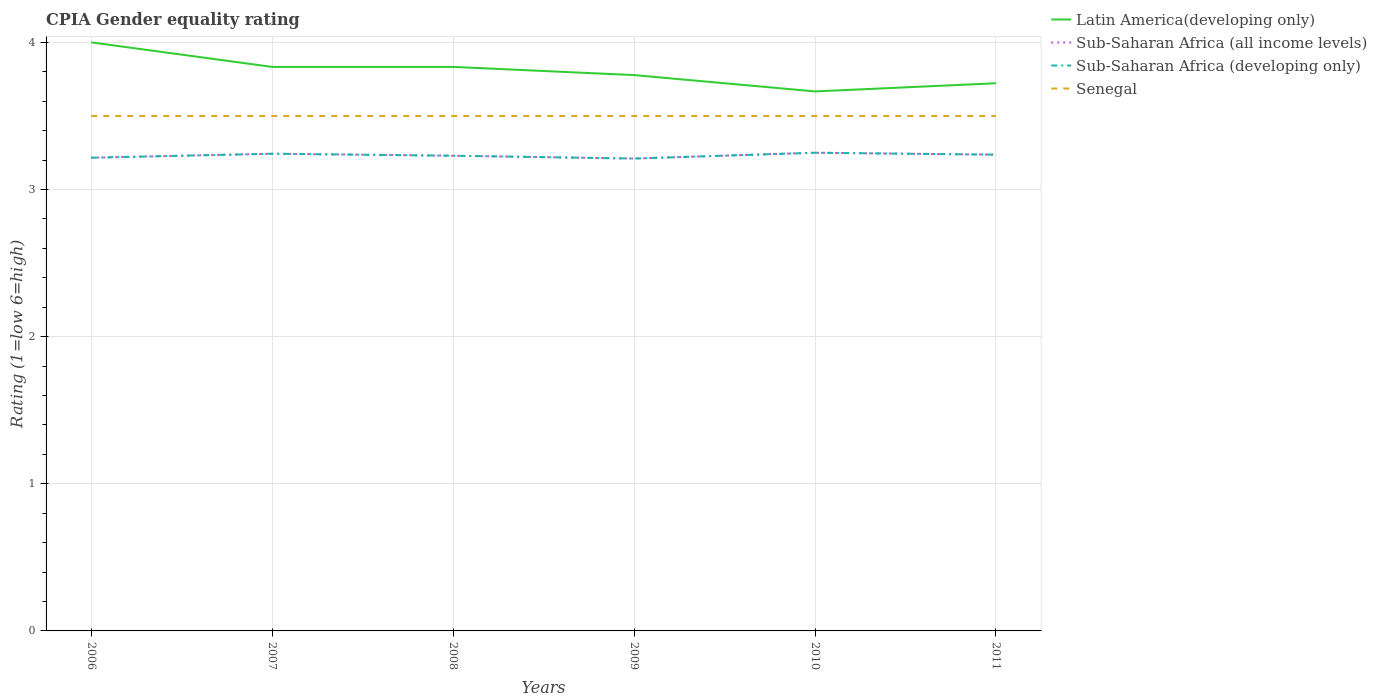How many different coloured lines are there?
Ensure brevity in your answer.  4. Does the line corresponding to Sub-Saharan Africa (developing only) intersect with the line corresponding to Latin America(developing only)?
Ensure brevity in your answer.  No. Across all years, what is the maximum CPIA rating in Sub-Saharan Africa (all income levels)?
Provide a short and direct response. 3.21. What is the total CPIA rating in Sub-Saharan Africa (all income levels) in the graph?
Offer a terse response. -0.02. What is the difference between the highest and the second highest CPIA rating in Sub-Saharan Africa (developing only)?
Ensure brevity in your answer.  0.04. Is the CPIA rating in Latin America(developing only) strictly greater than the CPIA rating in Senegal over the years?
Offer a terse response. No. Are the values on the major ticks of Y-axis written in scientific E-notation?
Keep it short and to the point. No. Does the graph contain grids?
Your answer should be compact. Yes. Where does the legend appear in the graph?
Offer a very short reply. Top right. How many legend labels are there?
Your answer should be very brief. 4. How are the legend labels stacked?
Keep it short and to the point. Vertical. What is the title of the graph?
Provide a short and direct response. CPIA Gender equality rating. Does "Azerbaijan" appear as one of the legend labels in the graph?
Your answer should be compact. No. What is the Rating (1=low 6=high) of Sub-Saharan Africa (all income levels) in 2006?
Your answer should be very brief. 3.22. What is the Rating (1=low 6=high) of Sub-Saharan Africa (developing only) in 2006?
Your answer should be compact. 3.22. What is the Rating (1=low 6=high) of Senegal in 2006?
Keep it short and to the point. 3.5. What is the Rating (1=low 6=high) of Latin America(developing only) in 2007?
Provide a short and direct response. 3.83. What is the Rating (1=low 6=high) of Sub-Saharan Africa (all income levels) in 2007?
Ensure brevity in your answer.  3.24. What is the Rating (1=low 6=high) in Sub-Saharan Africa (developing only) in 2007?
Keep it short and to the point. 3.24. What is the Rating (1=low 6=high) in Senegal in 2007?
Make the answer very short. 3.5. What is the Rating (1=low 6=high) in Latin America(developing only) in 2008?
Your answer should be compact. 3.83. What is the Rating (1=low 6=high) of Sub-Saharan Africa (all income levels) in 2008?
Your answer should be very brief. 3.23. What is the Rating (1=low 6=high) in Sub-Saharan Africa (developing only) in 2008?
Give a very brief answer. 3.23. What is the Rating (1=low 6=high) in Senegal in 2008?
Your answer should be compact. 3.5. What is the Rating (1=low 6=high) of Latin America(developing only) in 2009?
Offer a very short reply. 3.78. What is the Rating (1=low 6=high) of Sub-Saharan Africa (all income levels) in 2009?
Your response must be concise. 3.21. What is the Rating (1=low 6=high) in Sub-Saharan Africa (developing only) in 2009?
Ensure brevity in your answer.  3.21. What is the Rating (1=low 6=high) of Latin America(developing only) in 2010?
Ensure brevity in your answer.  3.67. What is the Rating (1=low 6=high) of Sub-Saharan Africa (developing only) in 2010?
Offer a very short reply. 3.25. What is the Rating (1=low 6=high) in Latin America(developing only) in 2011?
Give a very brief answer. 3.72. What is the Rating (1=low 6=high) of Sub-Saharan Africa (all income levels) in 2011?
Offer a very short reply. 3.24. What is the Rating (1=low 6=high) of Sub-Saharan Africa (developing only) in 2011?
Your answer should be compact. 3.24. Across all years, what is the maximum Rating (1=low 6=high) in Sub-Saharan Africa (all income levels)?
Offer a very short reply. 3.25. Across all years, what is the maximum Rating (1=low 6=high) of Sub-Saharan Africa (developing only)?
Provide a succinct answer. 3.25. Across all years, what is the maximum Rating (1=low 6=high) of Senegal?
Provide a succinct answer. 3.5. Across all years, what is the minimum Rating (1=low 6=high) in Latin America(developing only)?
Offer a terse response. 3.67. Across all years, what is the minimum Rating (1=low 6=high) of Sub-Saharan Africa (all income levels)?
Your answer should be compact. 3.21. Across all years, what is the minimum Rating (1=low 6=high) in Sub-Saharan Africa (developing only)?
Your answer should be very brief. 3.21. Across all years, what is the minimum Rating (1=low 6=high) in Senegal?
Ensure brevity in your answer.  3.5. What is the total Rating (1=low 6=high) in Latin America(developing only) in the graph?
Provide a succinct answer. 22.83. What is the total Rating (1=low 6=high) in Sub-Saharan Africa (all income levels) in the graph?
Give a very brief answer. 19.39. What is the total Rating (1=low 6=high) of Sub-Saharan Africa (developing only) in the graph?
Provide a short and direct response. 19.39. What is the total Rating (1=low 6=high) of Senegal in the graph?
Provide a succinct answer. 21. What is the difference between the Rating (1=low 6=high) in Latin America(developing only) in 2006 and that in 2007?
Give a very brief answer. 0.17. What is the difference between the Rating (1=low 6=high) of Sub-Saharan Africa (all income levels) in 2006 and that in 2007?
Your response must be concise. -0.03. What is the difference between the Rating (1=low 6=high) in Sub-Saharan Africa (developing only) in 2006 and that in 2007?
Offer a very short reply. -0.03. What is the difference between the Rating (1=low 6=high) in Senegal in 2006 and that in 2007?
Provide a short and direct response. 0. What is the difference between the Rating (1=low 6=high) of Latin America(developing only) in 2006 and that in 2008?
Provide a succinct answer. 0.17. What is the difference between the Rating (1=low 6=high) in Sub-Saharan Africa (all income levels) in 2006 and that in 2008?
Provide a succinct answer. -0.01. What is the difference between the Rating (1=low 6=high) in Sub-Saharan Africa (developing only) in 2006 and that in 2008?
Offer a very short reply. -0.01. What is the difference between the Rating (1=low 6=high) of Senegal in 2006 and that in 2008?
Your answer should be compact. 0. What is the difference between the Rating (1=low 6=high) of Latin America(developing only) in 2006 and that in 2009?
Offer a very short reply. 0.22. What is the difference between the Rating (1=low 6=high) of Sub-Saharan Africa (all income levels) in 2006 and that in 2009?
Keep it short and to the point. 0.01. What is the difference between the Rating (1=low 6=high) in Sub-Saharan Africa (developing only) in 2006 and that in 2009?
Make the answer very short. 0.01. What is the difference between the Rating (1=low 6=high) in Sub-Saharan Africa (all income levels) in 2006 and that in 2010?
Give a very brief answer. -0.03. What is the difference between the Rating (1=low 6=high) in Sub-Saharan Africa (developing only) in 2006 and that in 2010?
Your answer should be very brief. -0.03. What is the difference between the Rating (1=low 6=high) of Senegal in 2006 and that in 2010?
Keep it short and to the point. 0. What is the difference between the Rating (1=low 6=high) in Latin America(developing only) in 2006 and that in 2011?
Offer a terse response. 0.28. What is the difference between the Rating (1=low 6=high) of Sub-Saharan Africa (all income levels) in 2006 and that in 2011?
Provide a succinct answer. -0.02. What is the difference between the Rating (1=low 6=high) in Sub-Saharan Africa (developing only) in 2006 and that in 2011?
Give a very brief answer. -0.02. What is the difference between the Rating (1=low 6=high) in Sub-Saharan Africa (all income levels) in 2007 and that in 2008?
Offer a terse response. 0.01. What is the difference between the Rating (1=low 6=high) of Sub-Saharan Africa (developing only) in 2007 and that in 2008?
Your response must be concise. 0.01. What is the difference between the Rating (1=low 6=high) of Senegal in 2007 and that in 2008?
Make the answer very short. 0. What is the difference between the Rating (1=low 6=high) in Latin America(developing only) in 2007 and that in 2009?
Make the answer very short. 0.06. What is the difference between the Rating (1=low 6=high) of Sub-Saharan Africa (all income levels) in 2007 and that in 2009?
Offer a terse response. 0.03. What is the difference between the Rating (1=low 6=high) of Sub-Saharan Africa (developing only) in 2007 and that in 2009?
Your answer should be very brief. 0.03. What is the difference between the Rating (1=low 6=high) of Senegal in 2007 and that in 2009?
Make the answer very short. 0. What is the difference between the Rating (1=low 6=high) in Sub-Saharan Africa (all income levels) in 2007 and that in 2010?
Your response must be concise. -0.01. What is the difference between the Rating (1=low 6=high) of Sub-Saharan Africa (developing only) in 2007 and that in 2010?
Make the answer very short. -0.01. What is the difference between the Rating (1=low 6=high) of Senegal in 2007 and that in 2010?
Your answer should be very brief. 0. What is the difference between the Rating (1=low 6=high) of Latin America(developing only) in 2007 and that in 2011?
Your answer should be very brief. 0.11. What is the difference between the Rating (1=low 6=high) of Sub-Saharan Africa (all income levels) in 2007 and that in 2011?
Your response must be concise. 0.01. What is the difference between the Rating (1=low 6=high) in Sub-Saharan Africa (developing only) in 2007 and that in 2011?
Your answer should be very brief. 0.01. What is the difference between the Rating (1=low 6=high) in Latin America(developing only) in 2008 and that in 2009?
Provide a succinct answer. 0.06. What is the difference between the Rating (1=low 6=high) in Sub-Saharan Africa (all income levels) in 2008 and that in 2009?
Keep it short and to the point. 0.02. What is the difference between the Rating (1=low 6=high) of Sub-Saharan Africa (developing only) in 2008 and that in 2009?
Provide a succinct answer. 0.02. What is the difference between the Rating (1=low 6=high) in Senegal in 2008 and that in 2009?
Your response must be concise. 0. What is the difference between the Rating (1=low 6=high) of Sub-Saharan Africa (all income levels) in 2008 and that in 2010?
Offer a very short reply. -0.02. What is the difference between the Rating (1=low 6=high) in Sub-Saharan Africa (developing only) in 2008 and that in 2010?
Provide a succinct answer. -0.02. What is the difference between the Rating (1=low 6=high) of Sub-Saharan Africa (all income levels) in 2008 and that in 2011?
Your answer should be very brief. -0.01. What is the difference between the Rating (1=low 6=high) of Sub-Saharan Africa (developing only) in 2008 and that in 2011?
Your answer should be compact. -0.01. What is the difference between the Rating (1=low 6=high) of Senegal in 2008 and that in 2011?
Your response must be concise. 0. What is the difference between the Rating (1=low 6=high) of Latin America(developing only) in 2009 and that in 2010?
Make the answer very short. 0.11. What is the difference between the Rating (1=low 6=high) of Sub-Saharan Africa (all income levels) in 2009 and that in 2010?
Your answer should be very brief. -0.04. What is the difference between the Rating (1=low 6=high) in Sub-Saharan Africa (developing only) in 2009 and that in 2010?
Provide a short and direct response. -0.04. What is the difference between the Rating (1=low 6=high) in Senegal in 2009 and that in 2010?
Ensure brevity in your answer.  0. What is the difference between the Rating (1=low 6=high) in Latin America(developing only) in 2009 and that in 2011?
Make the answer very short. 0.06. What is the difference between the Rating (1=low 6=high) in Sub-Saharan Africa (all income levels) in 2009 and that in 2011?
Keep it short and to the point. -0.03. What is the difference between the Rating (1=low 6=high) of Sub-Saharan Africa (developing only) in 2009 and that in 2011?
Ensure brevity in your answer.  -0.03. What is the difference between the Rating (1=low 6=high) of Latin America(developing only) in 2010 and that in 2011?
Provide a succinct answer. -0.06. What is the difference between the Rating (1=low 6=high) of Sub-Saharan Africa (all income levels) in 2010 and that in 2011?
Provide a short and direct response. 0.01. What is the difference between the Rating (1=low 6=high) in Sub-Saharan Africa (developing only) in 2010 and that in 2011?
Your response must be concise. 0.01. What is the difference between the Rating (1=low 6=high) of Latin America(developing only) in 2006 and the Rating (1=low 6=high) of Sub-Saharan Africa (all income levels) in 2007?
Give a very brief answer. 0.76. What is the difference between the Rating (1=low 6=high) of Latin America(developing only) in 2006 and the Rating (1=low 6=high) of Sub-Saharan Africa (developing only) in 2007?
Offer a terse response. 0.76. What is the difference between the Rating (1=low 6=high) in Latin America(developing only) in 2006 and the Rating (1=low 6=high) in Senegal in 2007?
Your response must be concise. 0.5. What is the difference between the Rating (1=low 6=high) in Sub-Saharan Africa (all income levels) in 2006 and the Rating (1=low 6=high) in Sub-Saharan Africa (developing only) in 2007?
Keep it short and to the point. -0.03. What is the difference between the Rating (1=low 6=high) of Sub-Saharan Africa (all income levels) in 2006 and the Rating (1=low 6=high) of Senegal in 2007?
Offer a very short reply. -0.28. What is the difference between the Rating (1=low 6=high) in Sub-Saharan Africa (developing only) in 2006 and the Rating (1=low 6=high) in Senegal in 2007?
Provide a succinct answer. -0.28. What is the difference between the Rating (1=low 6=high) of Latin America(developing only) in 2006 and the Rating (1=low 6=high) of Sub-Saharan Africa (all income levels) in 2008?
Your answer should be very brief. 0.77. What is the difference between the Rating (1=low 6=high) in Latin America(developing only) in 2006 and the Rating (1=low 6=high) in Sub-Saharan Africa (developing only) in 2008?
Provide a succinct answer. 0.77. What is the difference between the Rating (1=low 6=high) in Sub-Saharan Africa (all income levels) in 2006 and the Rating (1=low 6=high) in Sub-Saharan Africa (developing only) in 2008?
Provide a succinct answer. -0.01. What is the difference between the Rating (1=low 6=high) in Sub-Saharan Africa (all income levels) in 2006 and the Rating (1=low 6=high) in Senegal in 2008?
Your answer should be very brief. -0.28. What is the difference between the Rating (1=low 6=high) in Sub-Saharan Africa (developing only) in 2006 and the Rating (1=low 6=high) in Senegal in 2008?
Make the answer very short. -0.28. What is the difference between the Rating (1=low 6=high) of Latin America(developing only) in 2006 and the Rating (1=low 6=high) of Sub-Saharan Africa (all income levels) in 2009?
Offer a terse response. 0.79. What is the difference between the Rating (1=low 6=high) in Latin America(developing only) in 2006 and the Rating (1=low 6=high) in Sub-Saharan Africa (developing only) in 2009?
Provide a short and direct response. 0.79. What is the difference between the Rating (1=low 6=high) in Latin America(developing only) in 2006 and the Rating (1=low 6=high) in Senegal in 2009?
Ensure brevity in your answer.  0.5. What is the difference between the Rating (1=low 6=high) of Sub-Saharan Africa (all income levels) in 2006 and the Rating (1=low 6=high) of Sub-Saharan Africa (developing only) in 2009?
Offer a terse response. 0.01. What is the difference between the Rating (1=low 6=high) of Sub-Saharan Africa (all income levels) in 2006 and the Rating (1=low 6=high) of Senegal in 2009?
Your answer should be very brief. -0.28. What is the difference between the Rating (1=low 6=high) of Sub-Saharan Africa (developing only) in 2006 and the Rating (1=low 6=high) of Senegal in 2009?
Offer a terse response. -0.28. What is the difference between the Rating (1=low 6=high) in Sub-Saharan Africa (all income levels) in 2006 and the Rating (1=low 6=high) in Sub-Saharan Africa (developing only) in 2010?
Provide a succinct answer. -0.03. What is the difference between the Rating (1=low 6=high) in Sub-Saharan Africa (all income levels) in 2006 and the Rating (1=low 6=high) in Senegal in 2010?
Give a very brief answer. -0.28. What is the difference between the Rating (1=low 6=high) in Sub-Saharan Africa (developing only) in 2006 and the Rating (1=low 6=high) in Senegal in 2010?
Give a very brief answer. -0.28. What is the difference between the Rating (1=low 6=high) in Latin America(developing only) in 2006 and the Rating (1=low 6=high) in Sub-Saharan Africa (all income levels) in 2011?
Give a very brief answer. 0.76. What is the difference between the Rating (1=low 6=high) of Latin America(developing only) in 2006 and the Rating (1=low 6=high) of Sub-Saharan Africa (developing only) in 2011?
Offer a very short reply. 0.76. What is the difference between the Rating (1=low 6=high) in Sub-Saharan Africa (all income levels) in 2006 and the Rating (1=low 6=high) in Sub-Saharan Africa (developing only) in 2011?
Ensure brevity in your answer.  -0.02. What is the difference between the Rating (1=low 6=high) in Sub-Saharan Africa (all income levels) in 2006 and the Rating (1=low 6=high) in Senegal in 2011?
Provide a short and direct response. -0.28. What is the difference between the Rating (1=low 6=high) in Sub-Saharan Africa (developing only) in 2006 and the Rating (1=low 6=high) in Senegal in 2011?
Offer a terse response. -0.28. What is the difference between the Rating (1=low 6=high) in Latin America(developing only) in 2007 and the Rating (1=low 6=high) in Sub-Saharan Africa (all income levels) in 2008?
Your answer should be very brief. 0.6. What is the difference between the Rating (1=low 6=high) of Latin America(developing only) in 2007 and the Rating (1=low 6=high) of Sub-Saharan Africa (developing only) in 2008?
Ensure brevity in your answer.  0.6. What is the difference between the Rating (1=low 6=high) of Latin America(developing only) in 2007 and the Rating (1=low 6=high) of Senegal in 2008?
Provide a succinct answer. 0.33. What is the difference between the Rating (1=low 6=high) in Sub-Saharan Africa (all income levels) in 2007 and the Rating (1=low 6=high) in Sub-Saharan Africa (developing only) in 2008?
Offer a very short reply. 0.01. What is the difference between the Rating (1=low 6=high) of Sub-Saharan Africa (all income levels) in 2007 and the Rating (1=low 6=high) of Senegal in 2008?
Offer a very short reply. -0.26. What is the difference between the Rating (1=low 6=high) in Sub-Saharan Africa (developing only) in 2007 and the Rating (1=low 6=high) in Senegal in 2008?
Your answer should be very brief. -0.26. What is the difference between the Rating (1=low 6=high) in Latin America(developing only) in 2007 and the Rating (1=low 6=high) in Sub-Saharan Africa (all income levels) in 2009?
Your answer should be compact. 0.62. What is the difference between the Rating (1=low 6=high) of Latin America(developing only) in 2007 and the Rating (1=low 6=high) of Sub-Saharan Africa (developing only) in 2009?
Your answer should be very brief. 0.62. What is the difference between the Rating (1=low 6=high) of Sub-Saharan Africa (all income levels) in 2007 and the Rating (1=low 6=high) of Sub-Saharan Africa (developing only) in 2009?
Your answer should be very brief. 0.03. What is the difference between the Rating (1=low 6=high) in Sub-Saharan Africa (all income levels) in 2007 and the Rating (1=low 6=high) in Senegal in 2009?
Keep it short and to the point. -0.26. What is the difference between the Rating (1=low 6=high) in Sub-Saharan Africa (developing only) in 2007 and the Rating (1=low 6=high) in Senegal in 2009?
Offer a very short reply. -0.26. What is the difference between the Rating (1=low 6=high) in Latin America(developing only) in 2007 and the Rating (1=low 6=high) in Sub-Saharan Africa (all income levels) in 2010?
Give a very brief answer. 0.58. What is the difference between the Rating (1=low 6=high) of Latin America(developing only) in 2007 and the Rating (1=low 6=high) of Sub-Saharan Africa (developing only) in 2010?
Keep it short and to the point. 0.58. What is the difference between the Rating (1=low 6=high) in Sub-Saharan Africa (all income levels) in 2007 and the Rating (1=low 6=high) in Sub-Saharan Africa (developing only) in 2010?
Your answer should be compact. -0.01. What is the difference between the Rating (1=low 6=high) of Sub-Saharan Africa (all income levels) in 2007 and the Rating (1=low 6=high) of Senegal in 2010?
Offer a terse response. -0.26. What is the difference between the Rating (1=low 6=high) in Sub-Saharan Africa (developing only) in 2007 and the Rating (1=low 6=high) in Senegal in 2010?
Your answer should be very brief. -0.26. What is the difference between the Rating (1=low 6=high) in Latin America(developing only) in 2007 and the Rating (1=low 6=high) in Sub-Saharan Africa (all income levels) in 2011?
Offer a terse response. 0.6. What is the difference between the Rating (1=low 6=high) of Latin America(developing only) in 2007 and the Rating (1=low 6=high) of Sub-Saharan Africa (developing only) in 2011?
Your answer should be very brief. 0.6. What is the difference between the Rating (1=low 6=high) of Sub-Saharan Africa (all income levels) in 2007 and the Rating (1=low 6=high) of Sub-Saharan Africa (developing only) in 2011?
Your answer should be very brief. 0.01. What is the difference between the Rating (1=low 6=high) in Sub-Saharan Africa (all income levels) in 2007 and the Rating (1=low 6=high) in Senegal in 2011?
Offer a very short reply. -0.26. What is the difference between the Rating (1=low 6=high) in Sub-Saharan Africa (developing only) in 2007 and the Rating (1=low 6=high) in Senegal in 2011?
Make the answer very short. -0.26. What is the difference between the Rating (1=low 6=high) in Latin America(developing only) in 2008 and the Rating (1=low 6=high) in Sub-Saharan Africa (all income levels) in 2009?
Ensure brevity in your answer.  0.62. What is the difference between the Rating (1=low 6=high) in Latin America(developing only) in 2008 and the Rating (1=low 6=high) in Sub-Saharan Africa (developing only) in 2009?
Offer a very short reply. 0.62. What is the difference between the Rating (1=low 6=high) of Sub-Saharan Africa (all income levels) in 2008 and the Rating (1=low 6=high) of Sub-Saharan Africa (developing only) in 2009?
Offer a terse response. 0.02. What is the difference between the Rating (1=low 6=high) of Sub-Saharan Africa (all income levels) in 2008 and the Rating (1=low 6=high) of Senegal in 2009?
Give a very brief answer. -0.27. What is the difference between the Rating (1=low 6=high) in Sub-Saharan Africa (developing only) in 2008 and the Rating (1=low 6=high) in Senegal in 2009?
Offer a very short reply. -0.27. What is the difference between the Rating (1=low 6=high) in Latin America(developing only) in 2008 and the Rating (1=low 6=high) in Sub-Saharan Africa (all income levels) in 2010?
Provide a succinct answer. 0.58. What is the difference between the Rating (1=low 6=high) in Latin America(developing only) in 2008 and the Rating (1=low 6=high) in Sub-Saharan Africa (developing only) in 2010?
Your answer should be compact. 0.58. What is the difference between the Rating (1=low 6=high) in Sub-Saharan Africa (all income levels) in 2008 and the Rating (1=low 6=high) in Sub-Saharan Africa (developing only) in 2010?
Your answer should be compact. -0.02. What is the difference between the Rating (1=low 6=high) of Sub-Saharan Africa (all income levels) in 2008 and the Rating (1=low 6=high) of Senegal in 2010?
Keep it short and to the point. -0.27. What is the difference between the Rating (1=low 6=high) in Sub-Saharan Africa (developing only) in 2008 and the Rating (1=low 6=high) in Senegal in 2010?
Provide a short and direct response. -0.27. What is the difference between the Rating (1=low 6=high) in Latin America(developing only) in 2008 and the Rating (1=low 6=high) in Sub-Saharan Africa (all income levels) in 2011?
Offer a very short reply. 0.6. What is the difference between the Rating (1=low 6=high) of Latin America(developing only) in 2008 and the Rating (1=low 6=high) of Sub-Saharan Africa (developing only) in 2011?
Provide a short and direct response. 0.6. What is the difference between the Rating (1=low 6=high) in Sub-Saharan Africa (all income levels) in 2008 and the Rating (1=low 6=high) in Sub-Saharan Africa (developing only) in 2011?
Make the answer very short. -0.01. What is the difference between the Rating (1=low 6=high) in Sub-Saharan Africa (all income levels) in 2008 and the Rating (1=low 6=high) in Senegal in 2011?
Give a very brief answer. -0.27. What is the difference between the Rating (1=low 6=high) of Sub-Saharan Africa (developing only) in 2008 and the Rating (1=low 6=high) of Senegal in 2011?
Your answer should be very brief. -0.27. What is the difference between the Rating (1=low 6=high) in Latin America(developing only) in 2009 and the Rating (1=low 6=high) in Sub-Saharan Africa (all income levels) in 2010?
Your answer should be very brief. 0.53. What is the difference between the Rating (1=low 6=high) in Latin America(developing only) in 2009 and the Rating (1=low 6=high) in Sub-Saharan Africa (developing only) in 2010?
Provide a succinct answer. 0.53. What is the difference between the Rating (1=low 6=high) of Latin America(developing only) in 2009 and the Rating (1=low 6=high) of Senegal in 2010?
Provide a short and direct response. 0.28. What is the difference between the Rating (1=low 6=high) in Sub-Saharan Africa (all income levels) in 2009 and the Rating (1=low 6=high) in Sub-Saharan Africa (developing only) in 2010?
Offer a very short reply. -0.04. What is the difference between the Rating (1=low 6=high) in Sub-Saharan Africa (all income levels) in 2009 and the Rating (1=low 6=high) in Senegal in 2010?
Your response must be concise. -0.29. What is the difference between the Rating (1=low 6=high) of Sub-Saharan Africa (developing only) in 2009 and the Rating (1=low 6=high) of Senegal in 2010?
Provide a short and direct response. -0.29. What is the difference between the Rating (1=low 6=high) of Latin America(developing only) in 2009 and the Rating (1=low 6=high) of Sub-Saharan Africa (all income levels) in 2011?
Provide a succinct answer. 0.54. What is the difference between the Rating (1=low 6=high) of Latin America(developing only) in 2009 and the Rating (1=low 6=high) of Sub-Saharan Africa (developing only) in 2011?
Your answer should be compact. 0.54. What is the difference between the Rating (1=low 6=high) of Latin America(developing only) in 2009 and the Rating (1=low 6=high) of Senegal in 2011?
Your answer should be very brief. 0.28. What is the difference between the Rating (1=low 6=high) of Sub-Saharan Africa (all income levels) in 2009 and the Rating (1=low 6=high) of Sub-Saharan Africa (developing only) in 2011?
Provide a succinct answer. -0.03. What is the difference between the Rating (1=low 6=high) of Sub-Saharan Africa (all income levels) in 2009 and the Rating (1=low 6=high) of Senegal in 2011?
Provide a succinct answer. -0.29. What is the difference between the Rating (1=low 6=high) in Sub-Saharan Africa (developing only) in 2009 and the Rating (1=low 6=high) in Senegal in 2011?
Ensure brevity in your answer.  -0.29. What is the difference between the Rating (1=low 6=high) in Latin America(developing only) in 2010 and the Rating (1=low 6=high) in Sub-Saharan Africa (all income levels) in 2011?
Offer a terse response. 0.43. What is the difference between the Rating (1=low 6=high) in Latin America(developing only) in 2010 and the Rating (1=low 6=high) in Sub-Saharan Africa (developing only) in 2011?
Make the answer very short. 0.43. What is the difference between the Rating (1=low 6=high) in Latin America(developing only) in 2010 and the Rating (1=low 6=high) in Senegal in 2011?
Offer a terse response. 0.17. What is the difference between the Rating (1=low 6=high) of Sub-Saharan Africa (all income levels) in 2010 and the Rating (1=low 6=high) of Sub-Saharan Africa (developing only) in 2011?
Give a very brief answer. 0.01. What is the difference between the Rating (1=low 6=high) in Sub-Saharan Africa (developing only) in 2010 and the Rating (1=low 6=high) in Senegal in 2011?
Your answer should be very brief. -0.25. What is the average Rating (1=low 6=high) in Latin America(developing only) per year?
Ensure brevity in your answer.  3.81. What is the average Rating (1=low 6=high) of Sub-Saharan Africa (all income levels) per year?
Ensure brevity in your answer.  3.23. What is the average Rating (1=low 6=high) of Sub-Saharan Africa (developing only) per year?
Make the answer very short. 3.23. In the year 2006, what is the difference between the Rating (1=low 6=high) of Latin America(developing only) and Rating (1=low 6=high) of Sub-Saharan Africa (all income levels)?
Your answer should be very brief. 0.78. In the year 2006, what is the difference between the Rating (1=low 6=high) of Latin America(developing only) and Rating (1=low 6=high) of Sub-Saharan Africa (developing only)?
Your answer should be compact. 0.78. In the year 2006, what is the difference between the Rating (1=low 6=high) in Sub-Saharan Africa (all income levels) and Rating (1=low 6=high) in Sub-Saharan Africa (developing only)?
Ensure brevity in your answer.  0. In the year 2006, what is the difference between the Rating (1=low 6=high) in Sub-Saharan Africa (all income levels) and Rating (1=low 6=high) in Senegal?
Your response must be concise. -0.28. In the year 2006, what is the difference between the Rating (1=low 6=high) in Sub-Saharan Africa (developing only) and Rating (1=low 6=high) in Senegal?
Keep it short and to the point. -0.28. In the year 2007, what is the difference between the Rating (1=low 6=high) of Latin America(developing only) and Rating (1=low 6=high) of Sub-Saharan Africa (all income levels)?
Offer a terse response. 0.59. In the year 2007, what is the difference between the Rating (1=low 6=high) in Latin America(developing only) and Rating (1=low 6=high) in Sub-Saharan Africa (developing only)?
Give a very brief answer. 0.59. In the year 2007, what is the difference between the Rating (1=low 6=high) of Sub-Saharan Africa (all income levels) and Rating (1=low 6=high) of Sub-Saharan Africa (developing only)?
Your answer should be compact. 0. In the year 2007, what is the difference between the Rating (1=low 6=high) of Sub-Saharan Africa (all income levels) and Rating (1=low 6=high) of Senegal?
Provide a succinct answer. -0.26. In the year 2007, what is the difference between the Rating (1=low 6=high) of Sub-Saharan Africa (developing only) and Rating (1=low 6=high) of Senegal?
Your answer should be very brief. -0.26. In the year 2008, what is the difference between the Rating (1=low 6=high) in Latin America(developing only) and Rating (1=low 6=high) in Sub-Saharan Africa (all income levels)?
Provide a short and direct response. 0.6. In the year 2008, what is the difference between the Rating (1=low 6=high) of Latin America(developing only) and Rating (1=low 6=high) of Sub-Saharan Africa (developing only)?
Your response must be concise. 0.6. In the year 2008, what is the difference between the Rating (1=low 6=high) in Latin America(developing only) and Rating (1=low 6=high) in Senegal?
Provide a short and direct response. 0.33. In the year 2008, what is the difference between the Rating (1=low 6=high) in Sub-Saharan Africa (all income levels) and Rating (1=low 6=high) in Sub-Saharan Africa (developing only)?
Provide a succinct answer. 0. In the year 2008, what is the difference between the Rating (1=low 6=high) of Sub-Saharan Africa (all income levels) and Rating (1=low 6=high) of Senegal?
Keep it short and to the point. -0.27. In the year 2008, what is the difference between the Rating (1=low 6=high) in Sub-Saharan Africa (developing only) and Rating (1=low 6=high) in Senegal?
Provide a short and direct response. -0.27. In the year 2009, what is the difference between the Rating (1=low 6=high) of Latin America(developing only) and Rating (1=low 6=high) of Sub-Saharan Africa (all income levels)?
Your answer should be compact. 0.57. In the year 2009, what is the difference between the Rating (1=low 6=high) of Latin America(developing only) and Rating (1=low 6=high) of Sub-Saharan Africa (developing only)?
Keep it short and to the point. 0.57. In the year 2009, what is the difference between the Rating (1=low 6=high) of Latin America(developing only) and Rating (1=low 6=high) of Senegal?
Give a very brief answer. 0.28. In the year 2009, what is the difference between the Rating (1=low 6=high) of Sub-Saharan Africa (all income levels) and Rating (1=low 6=high) of Senegal?
Make the answer very short. -0.29. In the year 2009, what is the difference between the Rating (1=low 6=high) of Sub-Saharan Africa (developing only) and Rating (1=low 6=high) of Senegal?
Your answer should be very brief. -0.29. In the year 2010, what is the difference between the Rating (1=low 6=high) in Latin America(developing only) and Rating (1=low 6=high) in Sub-Saharan Africa (all income levels)?
Make the answer very short. 0.42. In the year 2010, what is the difference between the Rating (1=low 6=high) of Latin America(developing only) and Rating (1=low 6=high) of Sub-Saharan Africa (developing only)?
Offer a very short reply. 0.42. In the year 2010, what is the difference between the Rating (1=low 6=high) of Sub-Saharan Africa (all income levels) and Rating (1=low 6=high) of Sub-Saharan Africa (developing only)?
Provide a succinct answer. 0. In the year 2011, what is the difference between the Rating (1=low 6=high) in Latin America(developing only) and Rating (1=low 6=high) in Sub-Saharan Africa (all income levels)?
Make the answer very short. 0.49. In the year 2011, what is the difference between the Rating (1=low 6=high) in Latin America(developing only) and Rating (1=low 6=high) in Sub-Saharan Africa (developing only)?
Your answer should be very brief. 0.49. In the year 2011, what is the difference between the Rating (1=low 6=high) of Latin America(developing only) and Rating (1=low 6=high) of Senegal?
Keep it short and to the point. 0.22. In the year 2011, what is the difference between the Rating (1=low 6=high) in Sub-Saharan Africa (all income levels) and Rating (1=low 6=high) in Senegal?
Offer a very short reply. -0.26. In the year 2011, what is the difference between the Rating (1=low 6=high) of Sub-Saharan Africa (developing only) and Rating (1=low 6=high) of Senegal?
Your response must be concise. -0.26. What is the ratio of the Rating (1=low 6=high) of Latin America(developing only) in 2006 to that in 2007?
Make the answer very short. 1.04. What is the ratio of the Rating (1=low 6=high) of Sub-Saharan Africa (all income levels) in 2006 to that in 2007?
Offer a very short reply. 0.99. What is the ratio of the Rating (1=low 6=high) of Sub-Saharan Africa (developing only) in 2006 to that in 2007?
Make the answer very short. 0.99. What is the ratio of the Rating (1=low 6=high) of Senegal in 2006 to that in 2007?
Make the answer very short. 1. What is the ratio of the Rating (1=low 6=high) of Latin America(developing only) in 2006 to that in 2008?
Your answer should be very brief. 1.04. What is the ratio of the Rating (1=low 6=high) of Senegal in 2006 to that in 2008?
Provide a succinct answer. 1. What is the ratio of the Rating (1=low 6=high) in Latin America(developing only) in 2006 to that in 2009?
Keep it short and to the point. 1.06. What is the ratio of the Rating (1=low 6=high) of Sub-Saharan Africa (all income levels) in 2006 to that in 2009?
Provide a short and direct response. 1. What is the ratio of the Rating (1=low 6=high) of Senegal in 2006 to that in 2009?
Your answer should be compact. 1. What is the ratio of the Rating (1=low 6=high) of Latin America(developing only) in 2006 to that in 2010?
Ensure brevity in your answer.  1.09. What is the ratio of the Rating (1=low 6=high) of Latin America(developing only) in 2006 to that in 2011?
Offer a terse response. 1.07. What is the ratio of the Rating (1=low 6=high) in Sub-Saharan Africa (all income levels) in 2006 to that in 2011?
Offer a terse response. 0.99. What is the ratio of the Rating (1=low 6=high) in Sub-Saharan Africa (developing only) in 2006 to that in 2011?
Your response must be concise. 0.99. What is the ratio of the Rating (1=low 6=high) of Senegal in 2006 to that in 2011?
Ensure brevity in your answer.  1. What is the ratio of the Rating (1=low 6=high) in Sub-Saharan Africa (developing only) in 2007 to that in 2008?
Ensure brevity in your answer.  1. What is the ratio of the Rating (1=low 6=high) of Latin America(developing only) in 2007 to that in 2009?
Your answer should be very brief. 1.01. What is the ratio of the Rating (1=low 6=high) in Sub-Saharan Africa (all income levels) in 2007 to that in 2009?
Your answer should be compact. 1.01. What is the ratio of the Rating (1=low 6=high) of Sub-Saharan Africa (developing only) in 2007 to that in 2009?
Make the answer very short. 1.01. What is the ratio of the Rating (1=low 6=high) of Latin America(developing only) in 2007 to that in 2010?
Ensure brevity in your answer.  1.05. What is the ratio of the Rating (1=low 6=high) of Latin America(developing only) in 2007 to that in 2011?
Keep it short and to the point. 1.03. What is the ratio of the Rating (1=low 6=high) in Latin America(developing only) in 2008 to that in 2009?
Offer a terse response. 1.01. What is the ratio of the Rating (1=low 6=high) of Sub-Saharan Africa (all income levels) in 2008 to that in 2009?
Your answer should be compact. 1.01. What is the ratio of the Rating (1=low 6=high) of Latin America(developing only) in 2008 to that in 2010?
Provide a short and direct response. 1.05. What is the ratio of the Rating (1=low 6=high) in Sub-Saharan Africa (all income levels) in 2008 to that in 2010?
Your answer should be very brief. 0.99. What is the ratio of the Rating (1=low 6=high) of Sub-Saharan Africa (developing only) in 2008 to that in 2010?
Provide a short and direct response. 0.99. What is the ratio of the Rating (1=low 6=high) of Senegal in 2008 to that in 2010?
Your response must be concise. 1. What is the ratio of the Rating (1=low 6=high) of Latin America(developing only) in 2008 to that in 2011?
Make the answer very short. 1.03. What is the ratio of the Rating (1=low 6=high) of Sub-Saharan Africa (all income levels) in 2008 to that in 2011?
Make the answer very short. 1. What is the ratio of the Rating (1=low 6=high) in Latin America(developing only) in 2009 to that in 2010?
Offer a very short reply. 1.03. What is the ratio of the Rating (1=low 6=high) in Sub-Saharan Africa (all income levels) in 2009 to that in 2010?
Provide a succinct answer. 0.99. What is the ratio of the Rating (1=low 6=high) in Sub-Saharan Africa (developing only) in 2009 to that in 2010?
Offer a terse response. 0.99. What is the ratio of the Rating (1=low 6=high) in Latin America(developing only) in 2009 to that in 2011?
Your response must be concise. 1.01. What is the ratio of the Rating (1=low 6=high) of Sub-Saharan Africa (all income levels) in 2009 to that in 2011?
Your answer should be compact. 0.99. What is the ratio of the Rating (1=low 6=high) in Senegal in 2009 to that in 2011?
Provide a short and direct response. 1. What is the ratio of the Rating (1=low 6=high) in Latin America(developing only) in 2010 to that in 2011?
Ensure brevity in your answer.  0.99. What is the ratio of the Rating (1=low 6=high) of Sub-Saharan Africa (developing only) in 2010 to that in 2011?
Make the answer very short. 1. What is the difference between the highest and the second highest Rating (1=low 6=high) of Sub-Saharan Africa (all income levels)?
Provide a short and direct response. 0.01. What is the difference between the highest and the second highest Rating (1=low 6=high) in Sub-Saharan Africa (developing only)?
Your response must be concise. 0.01. What is the difference between the highest and the second highest Rating (1=low 6=high) of Senegal?
Make the answer very short. 0. What is the difference between the highest and the lowest Rating (1=low 6=high) in Latin America(developing only)?
Ensure brevity in your answer.  0.33. What is the difference between the highest and the lowest Rating (1=low 6=high) of Sub-Saharan Africa (all income levels)?
Ensure brevity in your answer.  0.04. What is the difference between the highest and the lowest Rating (1=low 6=high) of Sub-Saharan Africa (developing only)?
Make the answer very short. 0.04. What is the difference between the highest and the lowest Rating (1=low 6=high) of Senegal?
Your answer should be very brief. 0. 